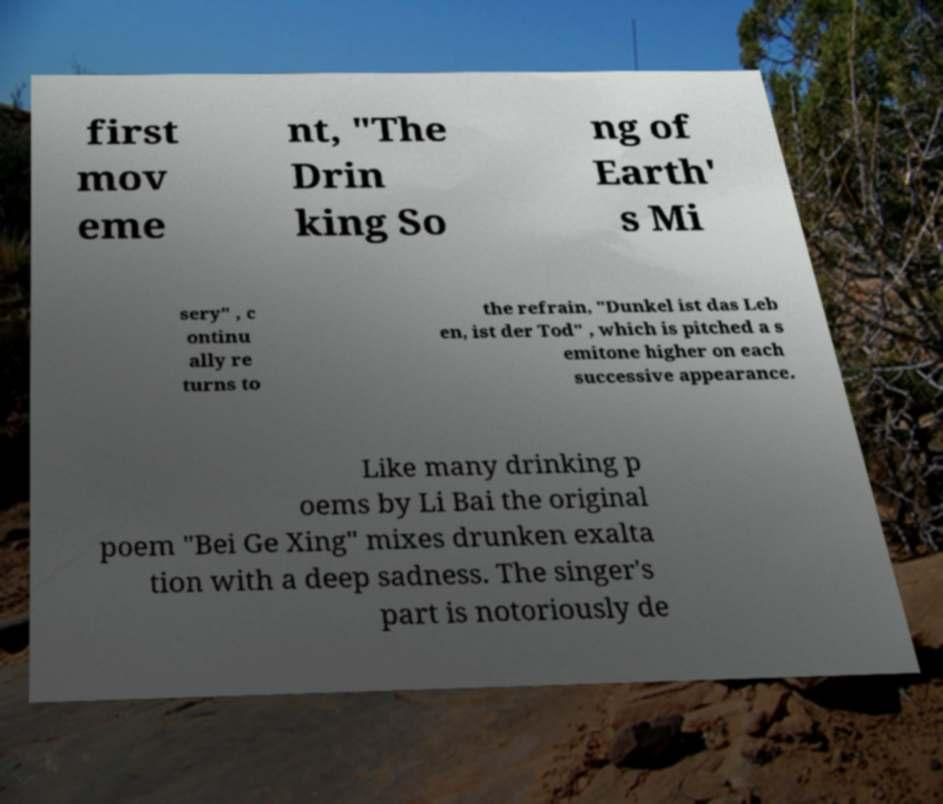Please identify and transcribe the text found in this image. first mov eme nt, "The Drin king So ng of Earth' s Mi sery" , c ontinu ally re turns to the refrain, "Dunkel ist das Leb en, ist der Tod" , which is pitched a s emitone higher on each successive appearance. Like many drinking p oems by Li Bai the original poem "Bei Ge Xing" mixes drunken exalta tion with a deep sadness. The singer's part is notoriously de 